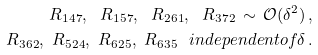Convert formula to latex. <formula><loc_0><loc_0><loc_500><loc_500>R _ { 1 4 7 } , \ R _ { 1 5 7 } , \ R _ { 2 6 1 } , \ R _ { 3 7 2 } \, \sim \, \mathcal { O } ( { \delta ^ { 2 } } ) \, , \\ R _ { 3 6 2 } , \ R _ { 5 2 4 } , \ R _ { 6 2 5 } , \ R _ { 6 3 5 } \ \ i n d e p e n d e n t o f \delta \, .</formula> 